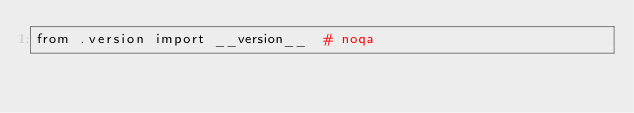Convert code to text. <code><loc_0><loc_0><loc_500><loc_500><_Python_>from .version import __version__  # noqa
</code> 